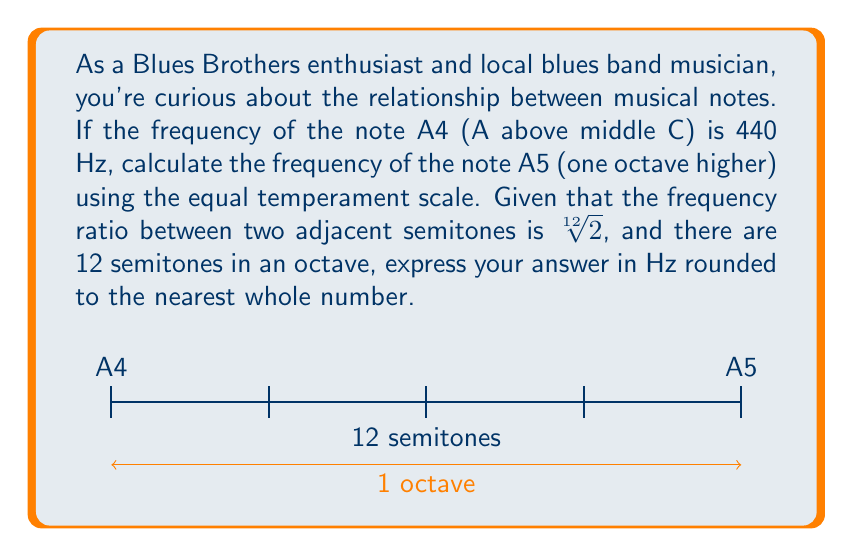Solve this math problem. Let's approach this step-by-step:

1) In the equal temperament scale, the frequency ratio between two adjacent semitones is $\sqrt[12]{2}$.

2) There are 12 semitones in an octave. Therefore, the frequency ratio between a note and the same note one octave higher is:

   $$(\sqrt[12]{2})^{12} = 2$$

3) This means that the frequency of a note doubles for each octave increase.

4) We're given that the frequency of A4 is 440 Hz. We need to find the frequency of A5, which is one octave higher.

5) Let's call the frequency of A5 as $f$. We can set up the equation:

   $$\frac{f}{440} = 2$$

6) Solving for $f$:

   $$f = 440 \times 2 = 880\text{ Hz}$$

7) The question asks for the answer rounded to the nearest whole number, but 880 is already a whole number.
Answer: 880 Hz 